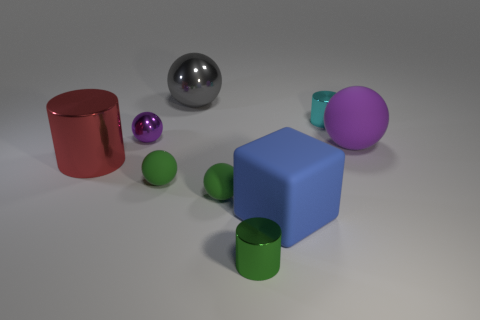Subtract all yellow balls. Subtract all blue blocks. How many balls are left? 5 Add 1 cyan objects. How many objects exist? 10 Subtract all cylinders. How many objects are left? 6 Add 1 tiny metallic balls. How many tiny metallic balls exist? 2 Subtract 1 blue cubes. How many objects are left? 8 Subtract all green things. Subtract all purple spheres. How many objects are left? 4 Add 5 purple matte things. How many purple matte things are left? 6 